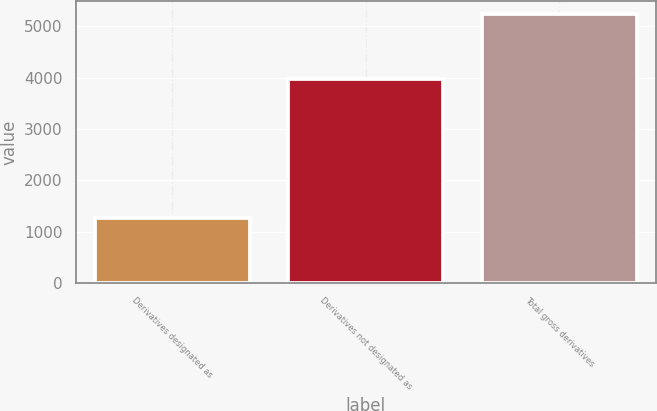Convert chart. <chart><loc_0><loc_0><loc_500><loc_500><bar_chart><fcel>Derivatives designated as<fcel>Derivatives not designated as<fcel>Total gross derivatives<nl><fcel>1261<fcel>3973<fcel>5234<nl></chart> 